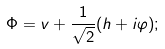<formula> <loc_0><loc_0><loc_500><loc_500>\Phi = v + \frac { 1 } { \sqrt { 2 } } ( h + i \varphi ) ;</formula> 